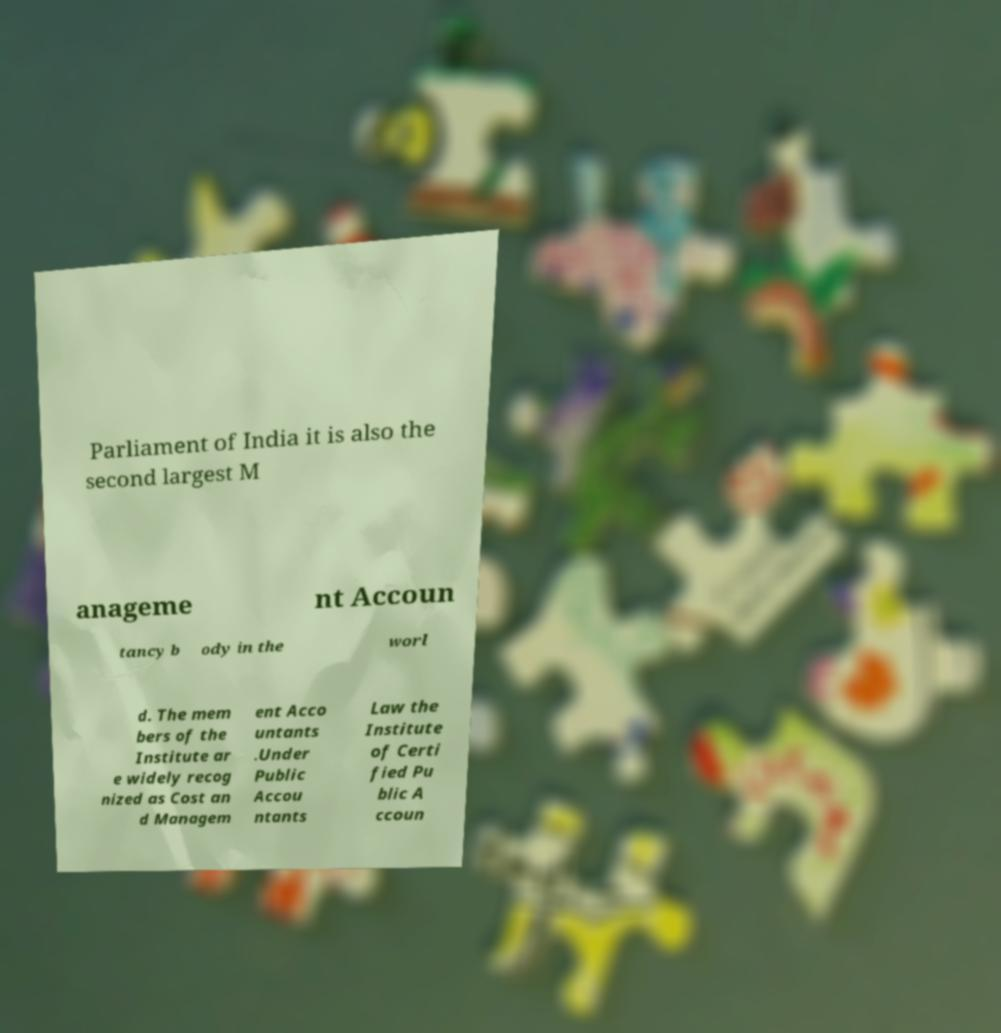What messages or text are displayed in this image? I need them in a readable, typed format. Parliament of India it is also the second largest M anageme nt Accoun tancy b ody in the worl d. The mem bers of the Institute ar e widely recog nized as Cost an d Managem ent Acco untants .Under Public Accou ntants Law the Institute of Certi fied Pu blic A ccoun 